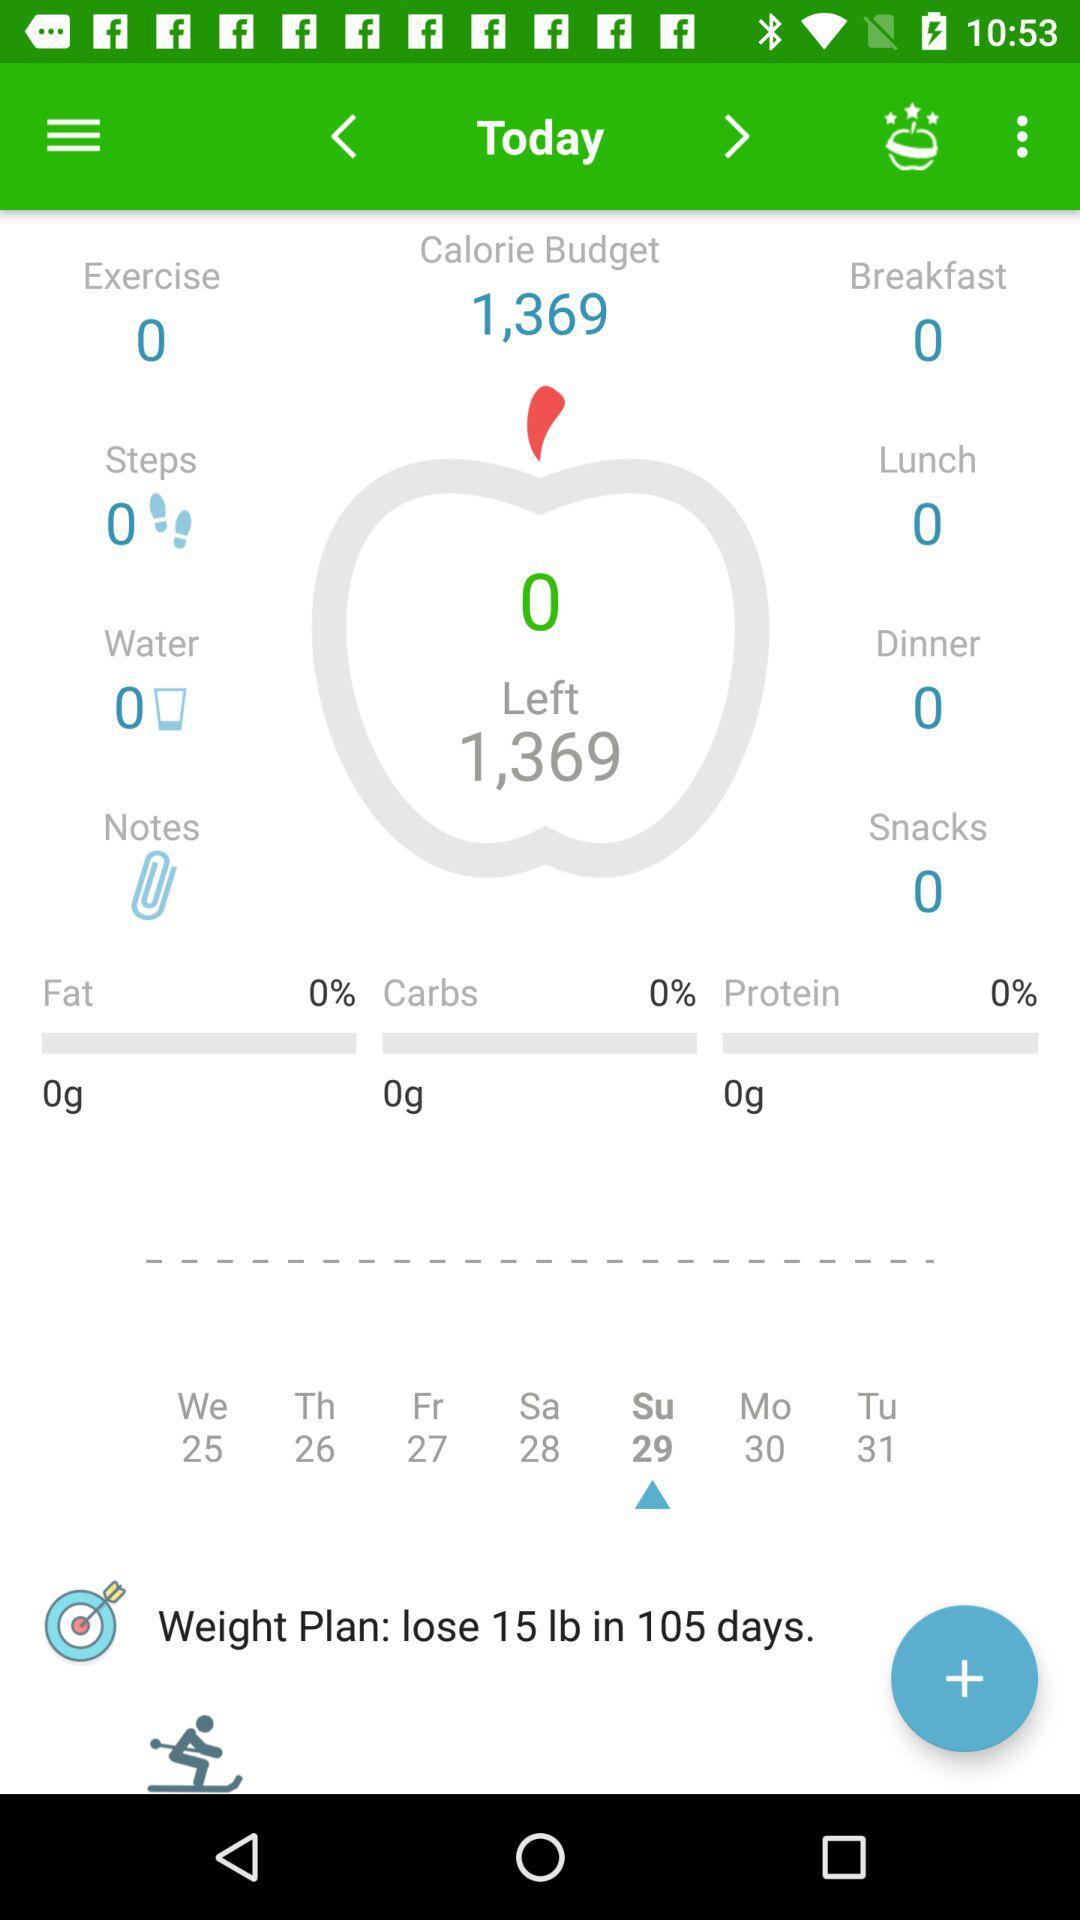What is the "Weight Plan"? The "Weight Plan" is to lose 15 lbs in 105 days. 